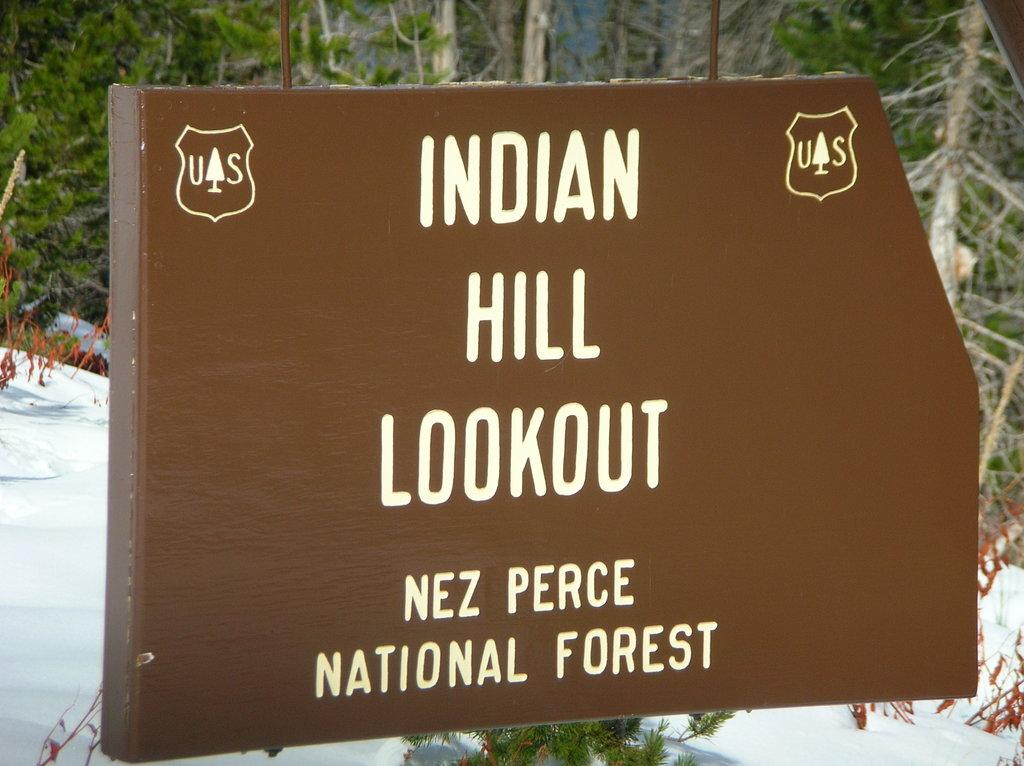What is the main object in the image? There is a board in the image. What is on the board? There is white matter on the board. What can be seen in the background of the image? There are trees in the background of the image. What is the weather condition on the left side of the image? There is snow on the left side of the image. How far away is the writer from the board in the image? There is no writer present in the image, so it is not possible to determine the distance between a writer and the board. 